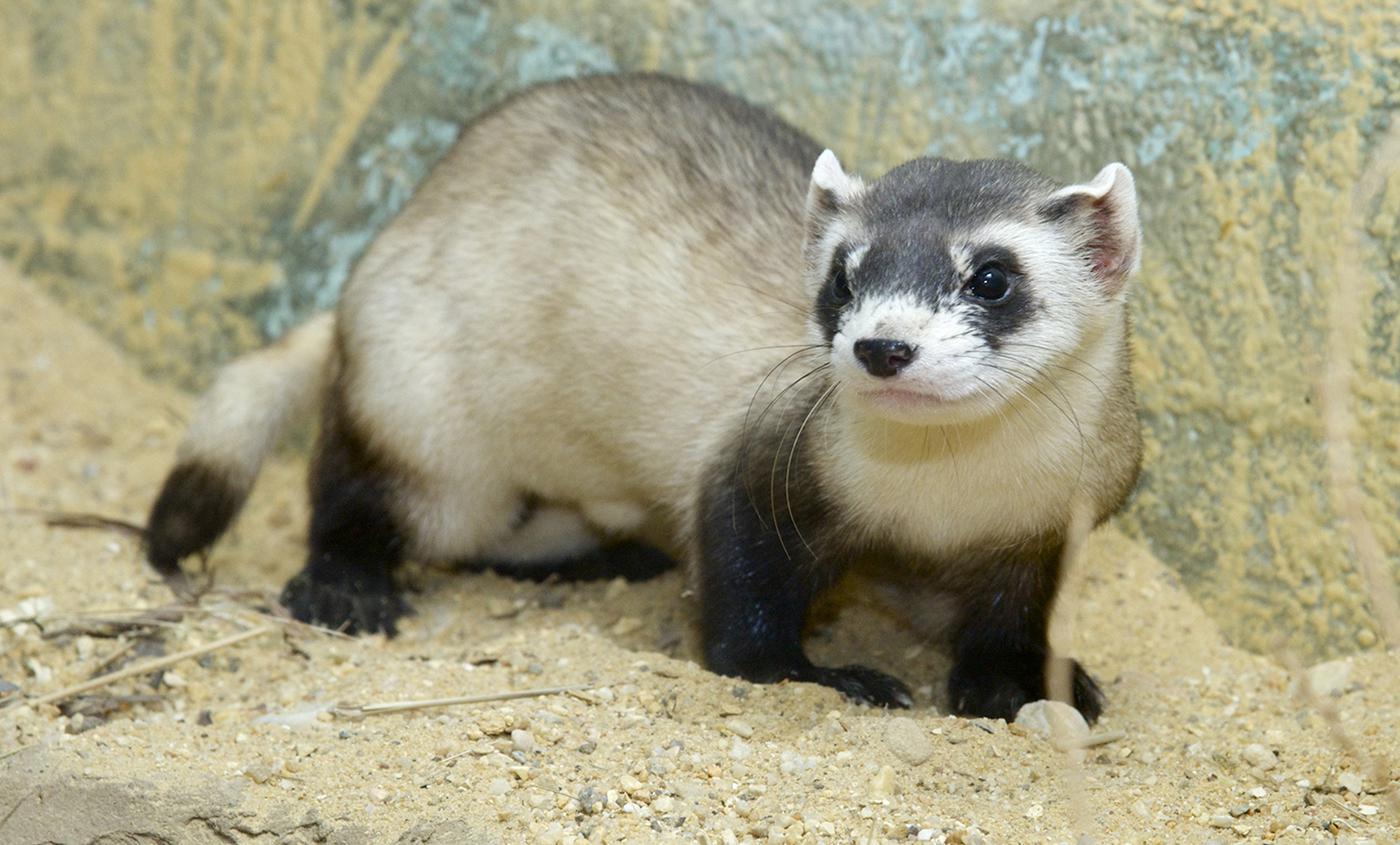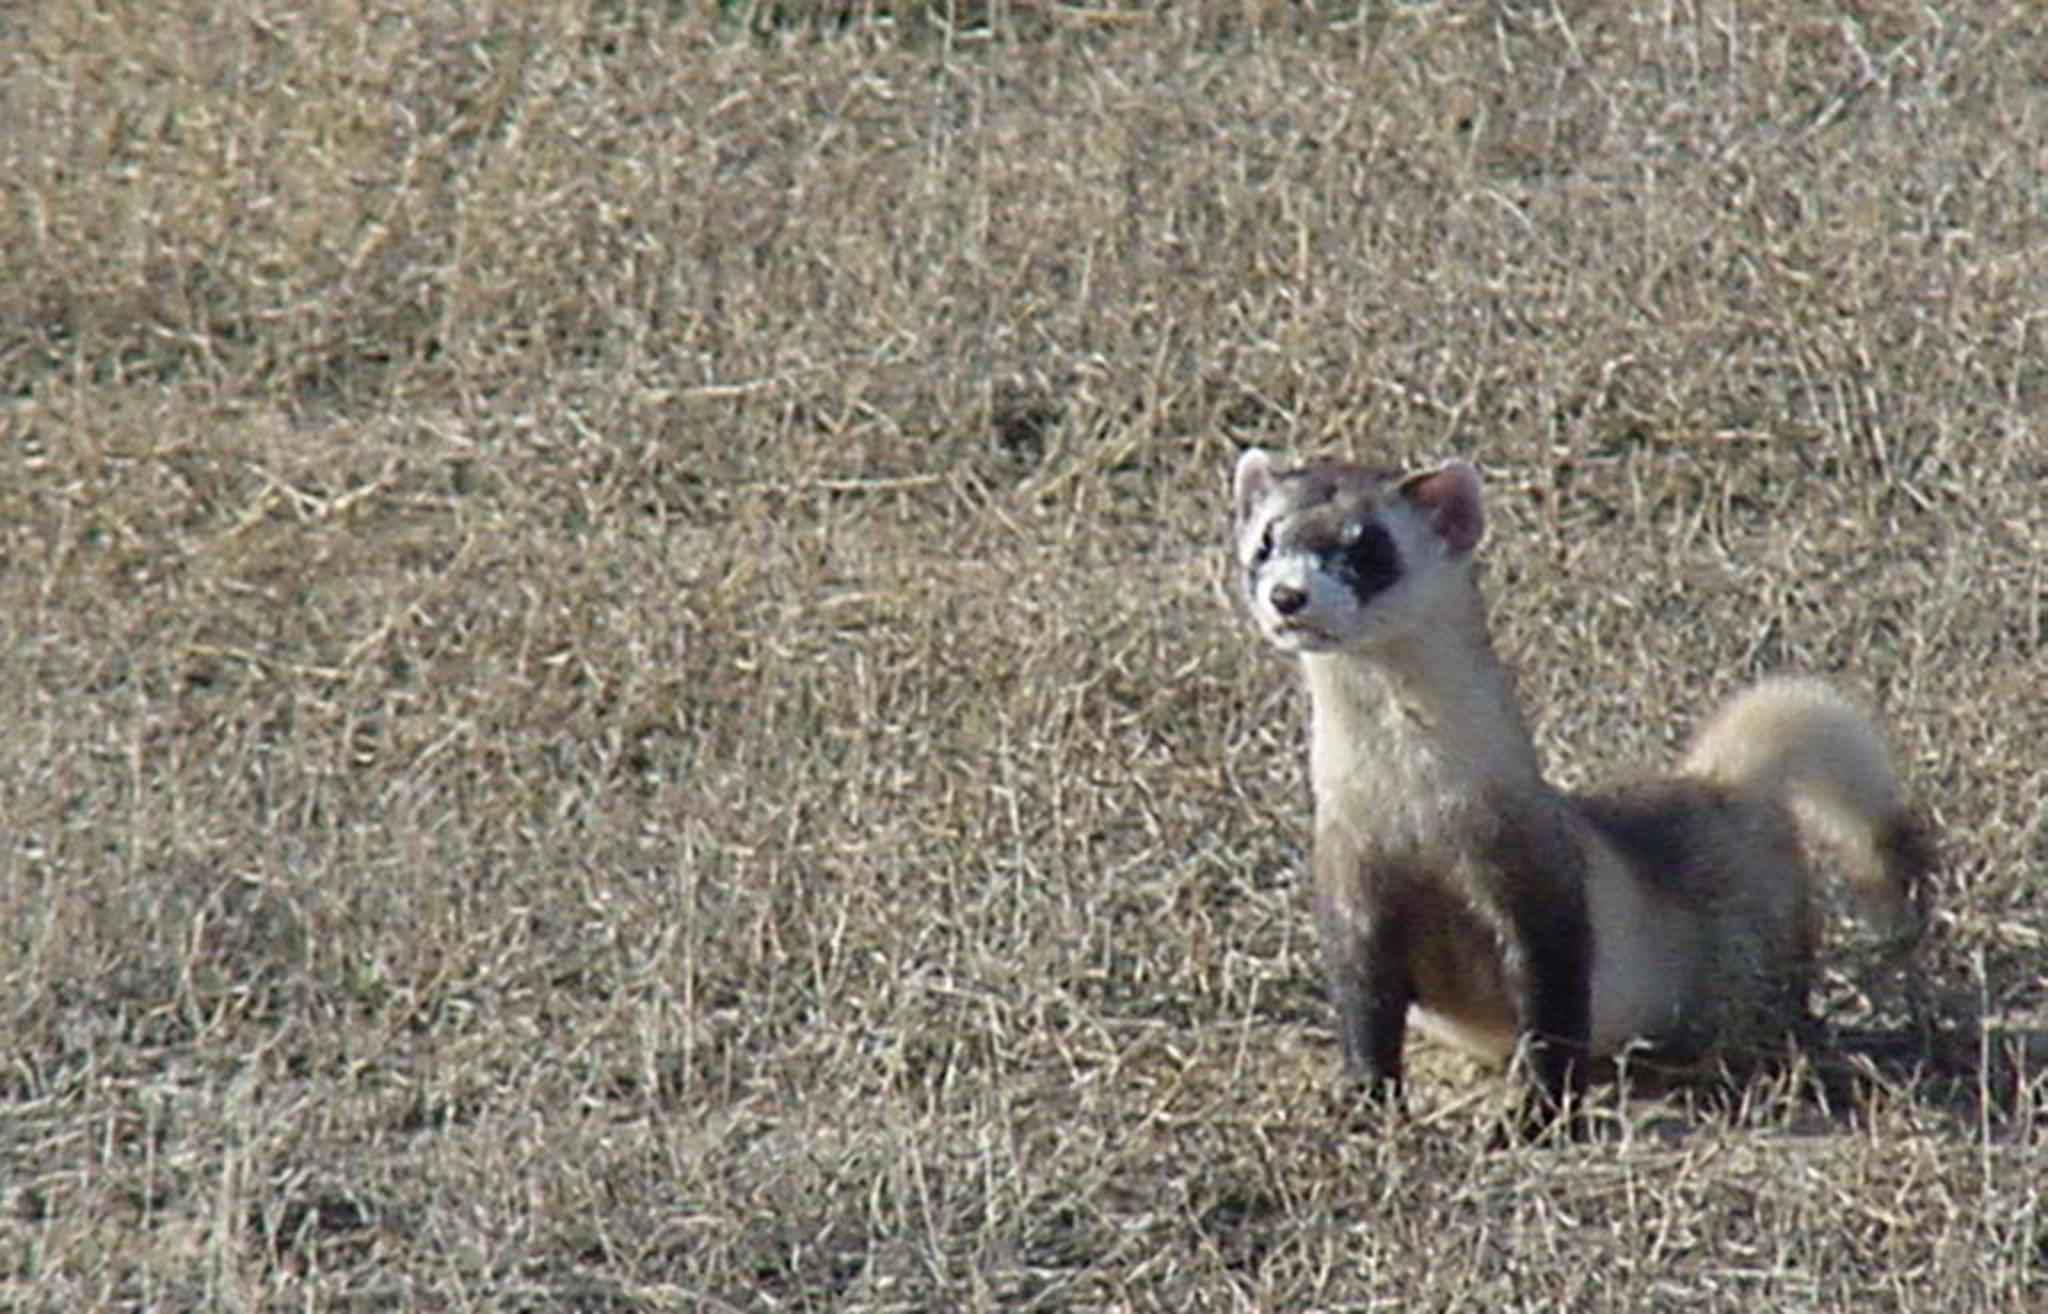The first image is the image on the left, the second image is the image on the right. Given the left and right images, does the statement "At least one of the animals is partly in a hole." hold true? Answer yes or no. No. The first image is the image on the left, the second image is the image on the right. For the images shown, is this caption "There are no more than two ferrets." true? Answer yes or no. Yes. 